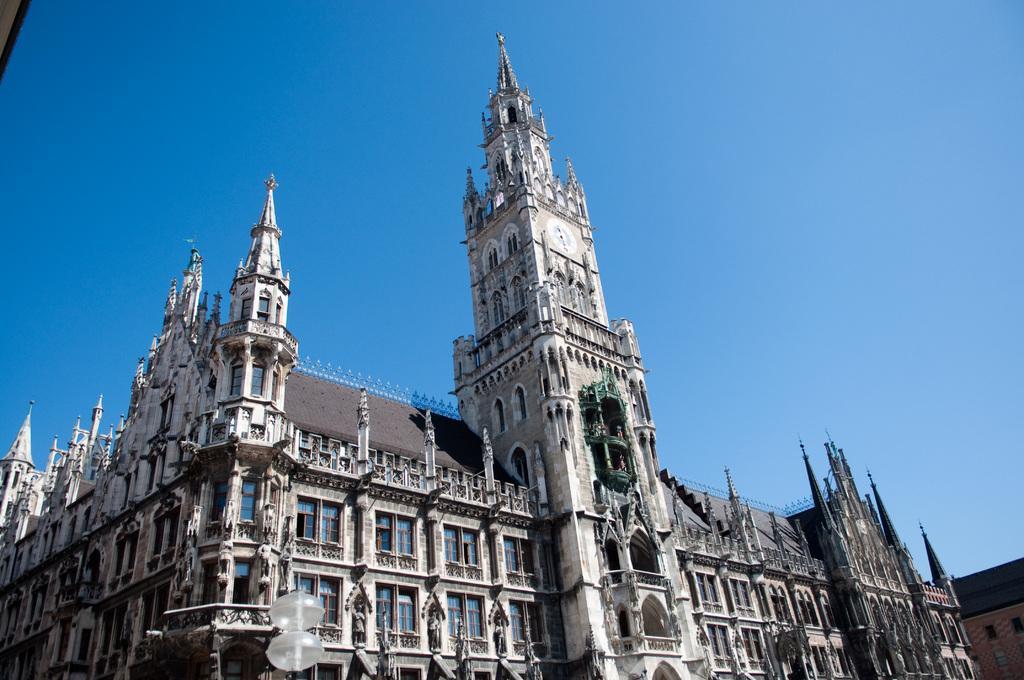Can you describe this image briefly? In this image there is a building. There are windows to the walls of the building. On the top of the building there is a clock to the wall. At the top there is the sky. At the bottom there are street lights to a pole. 